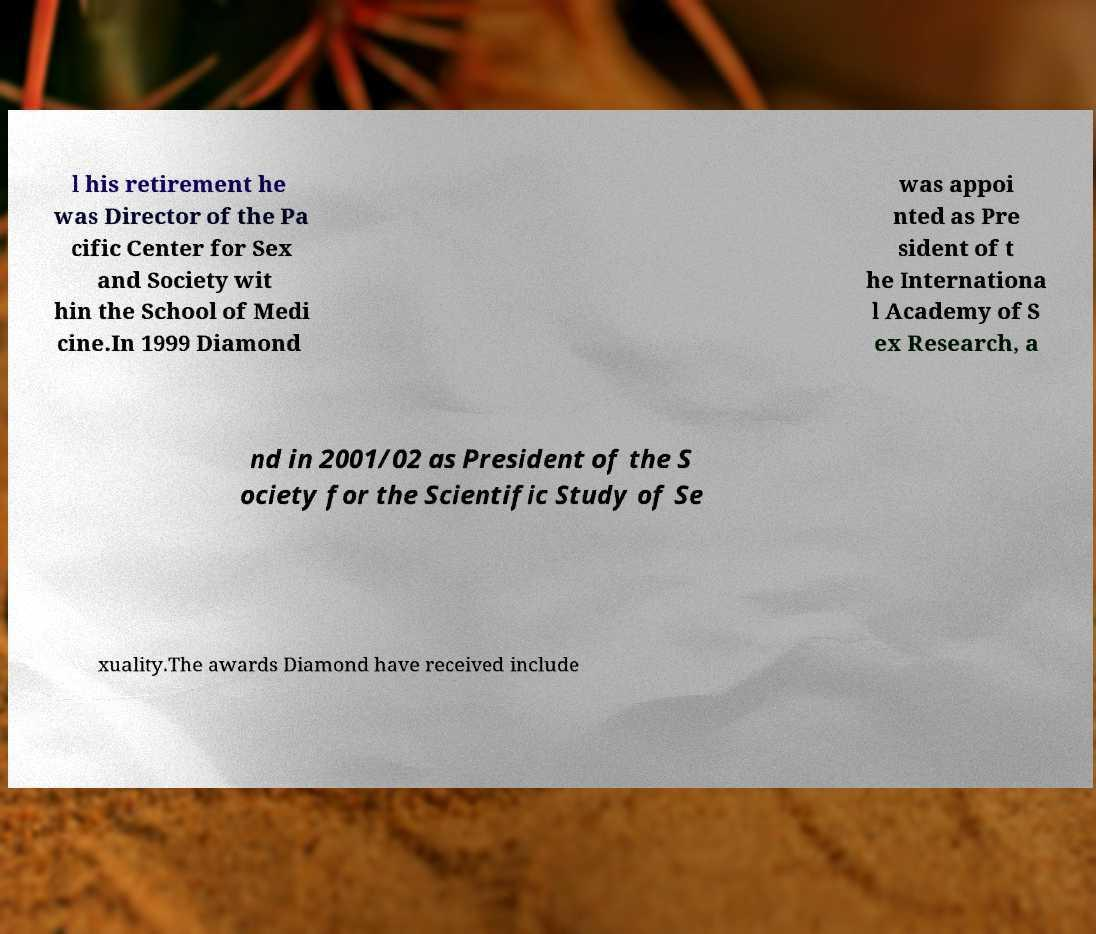What messages or text are displayed in this image? I need them in a readable, typed format. l his retirement he was Director of the Pa cific Center for Sex and Society wit hin the School of Medi cine.In 1999 Diamond was appoi nted as Pre sident of t he Internationa l Academy of S ex Research, a nd in 2001/02 as President of the S ociety for the Scientific Study of Se xuality.The awards Diamond have received include 